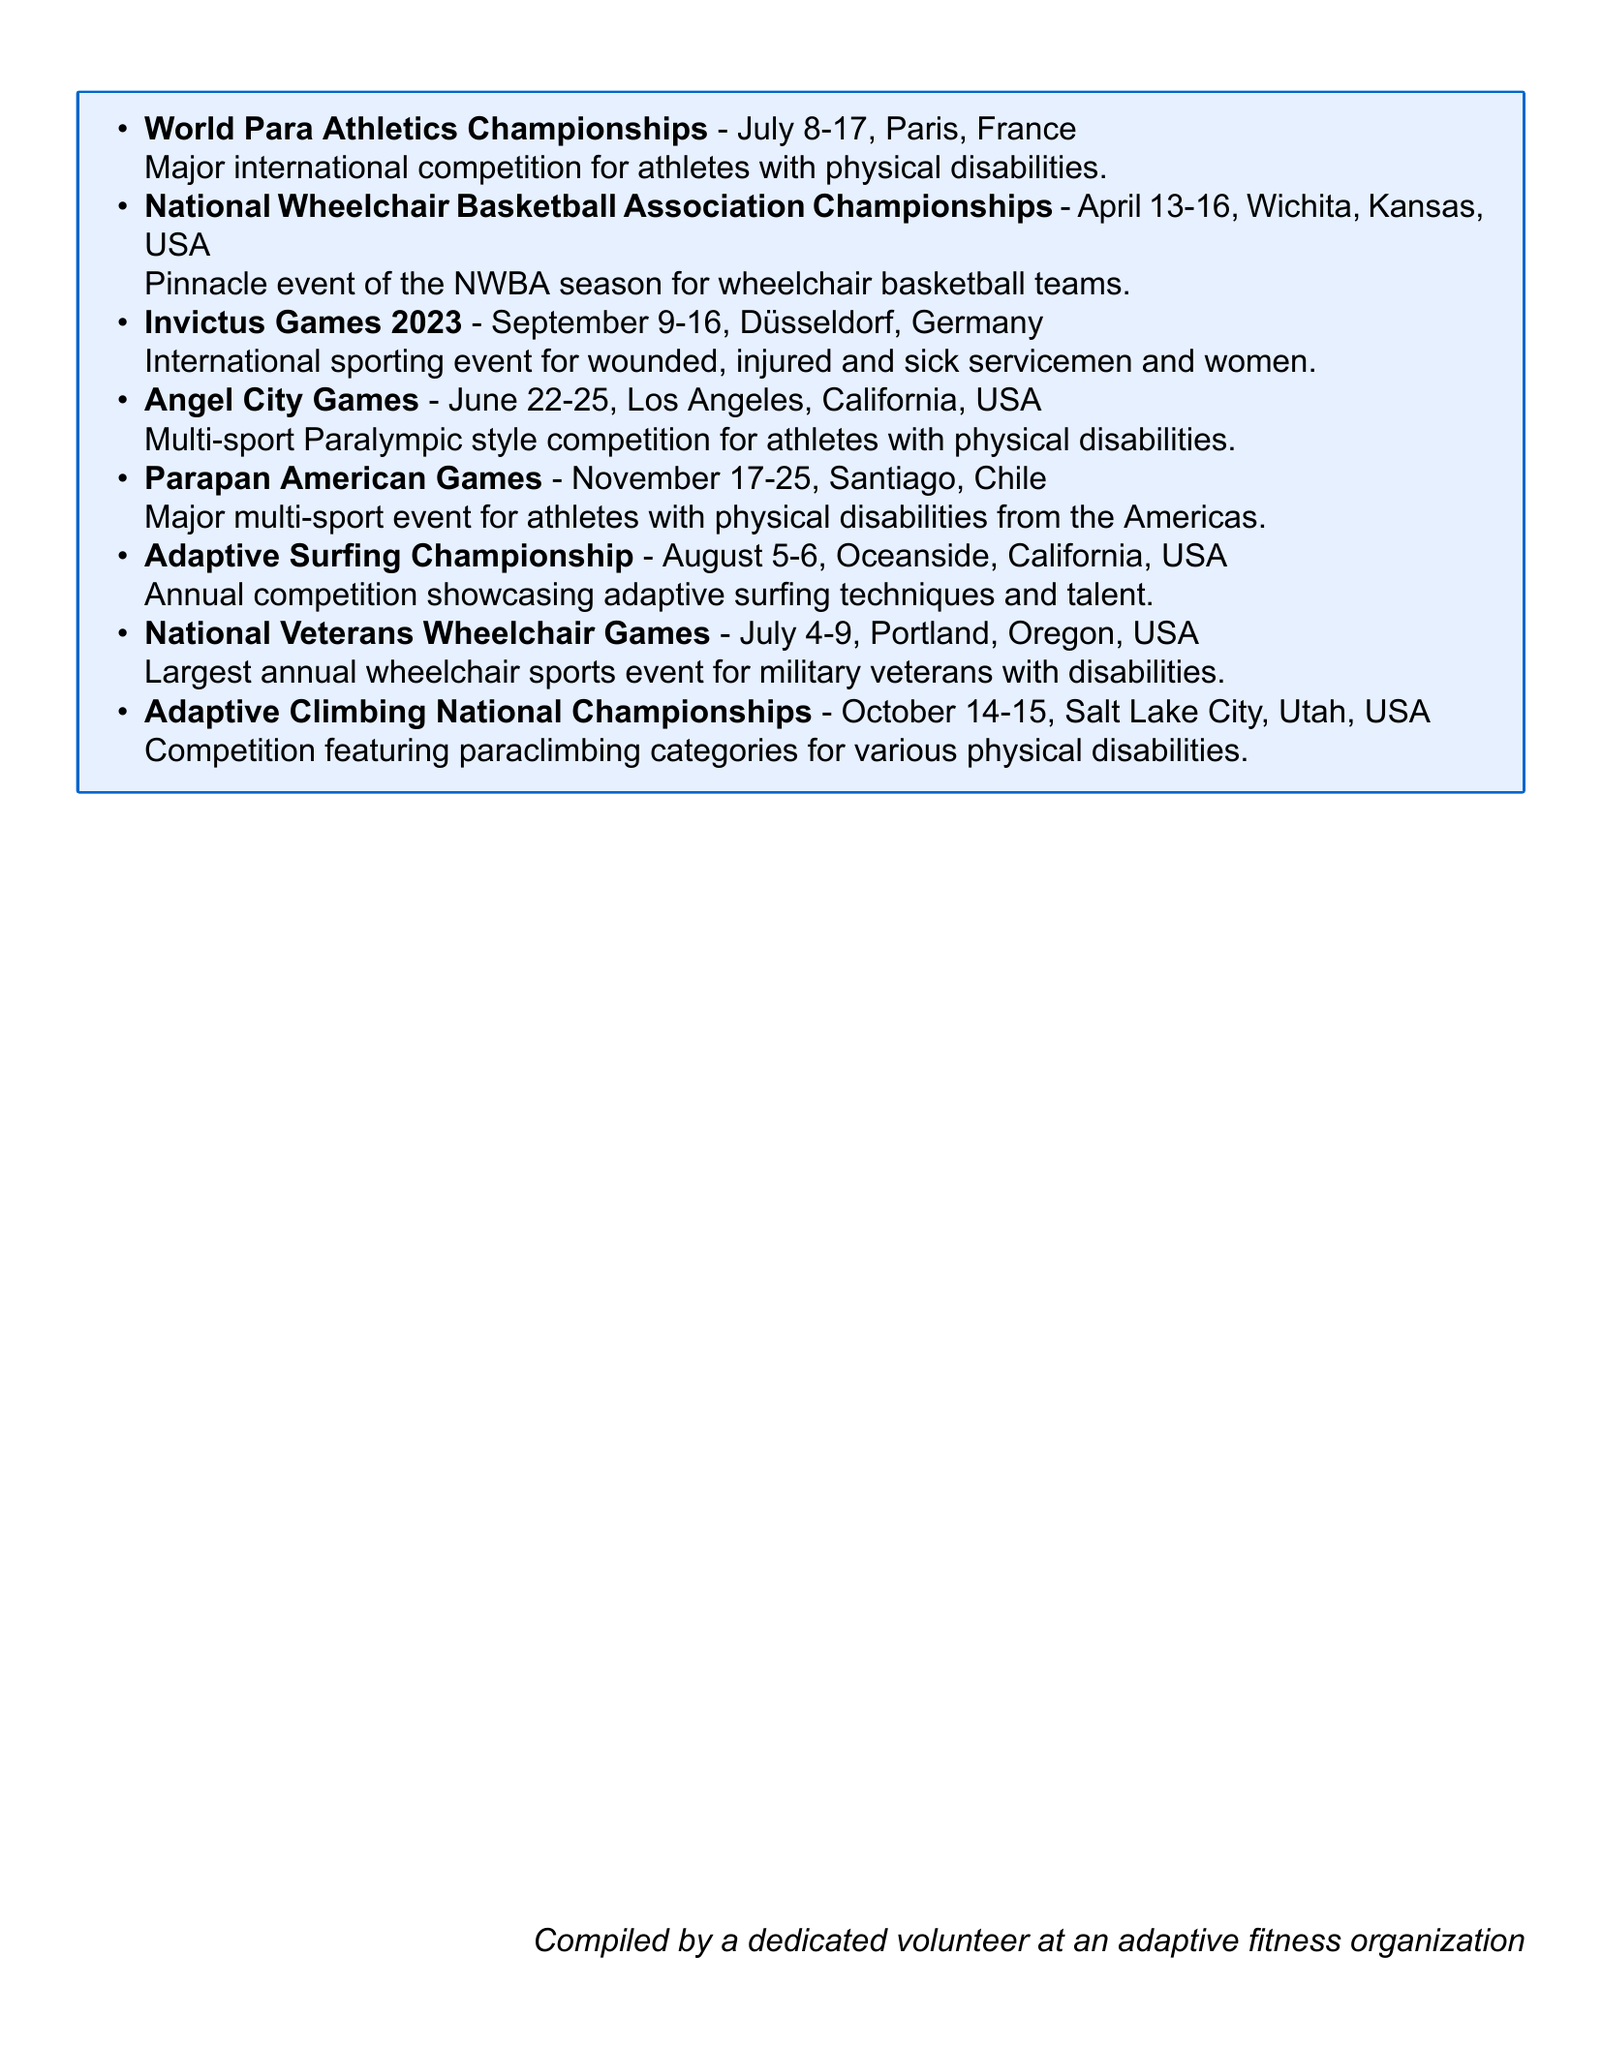What is the date of the National Wheelchair Basketball Association Championships? The date is specified in the document as April 13-16, 2023.
Answer: April 13-16, 2023 Where will the 2023 World Para Athletics Championships be held? The document states that it will be held in Paris, France.
Answer: Paris, France Which event is taking place in August? The document lists the Adaptive Surfing Championship under the month of August.
Answer: Adaptive Surfing Championship What is the significance of the Invictus Games 2023? The document mentions it as an opportunity to highlight the importance of adaptive sports in rehabilitation and recovery.
Answer: Importance of adaptive sports in rehabilitation and recovery How many events are scheduled in July? The document lists three events in July, thus counting the specific entries for that month.
Answer: Three events What is one potential benefit of the Angel City Games? The document states it could be a local event for participation or volunteering opportunities.
Answer: Potential local event for our organization to participate in or volunteer at When is the Adaptive Climbing National Championships scheduled? The document specifies the date as October 14-15, 2023.
Answer: October 14-15, 2023 What type of athletes participate in the Parapan American Games? The document states it is for athletes with physical disabilities from the Americas.
Answer: Athletes with physical disabilities from the Americas 